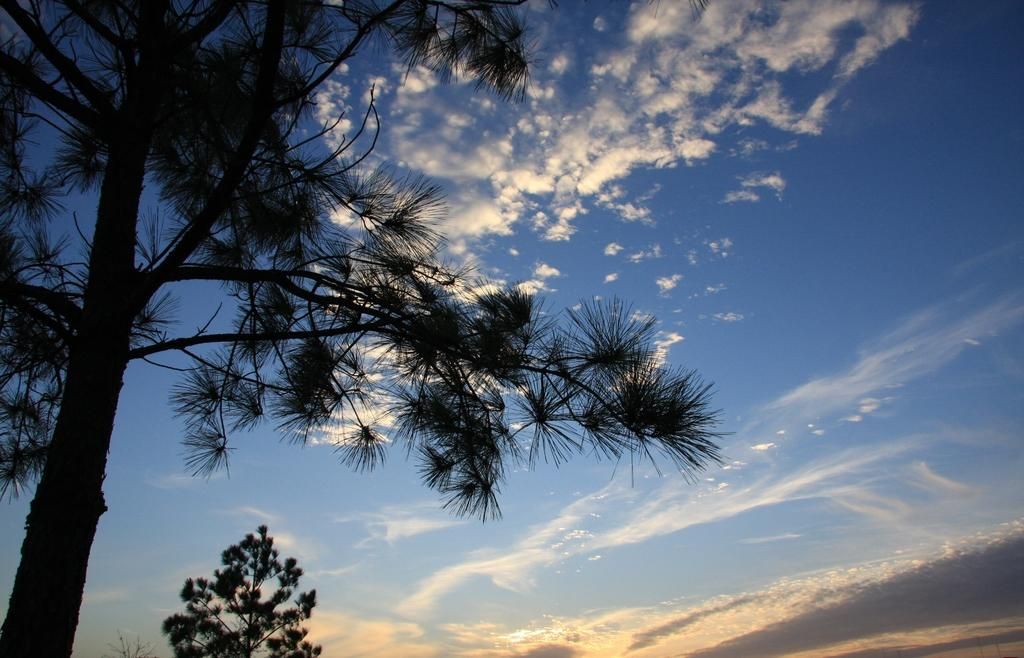What is located in the foreground of the image on the left side? There is a tree in the foreground of the image on the left side. What can be seen in the background of the image? There is another tree in the background of the image, and the sky is also visible. What type of blood is visible on the leaves of the tree in the image? There is no blood visible on the leaves of the tree in the image. 